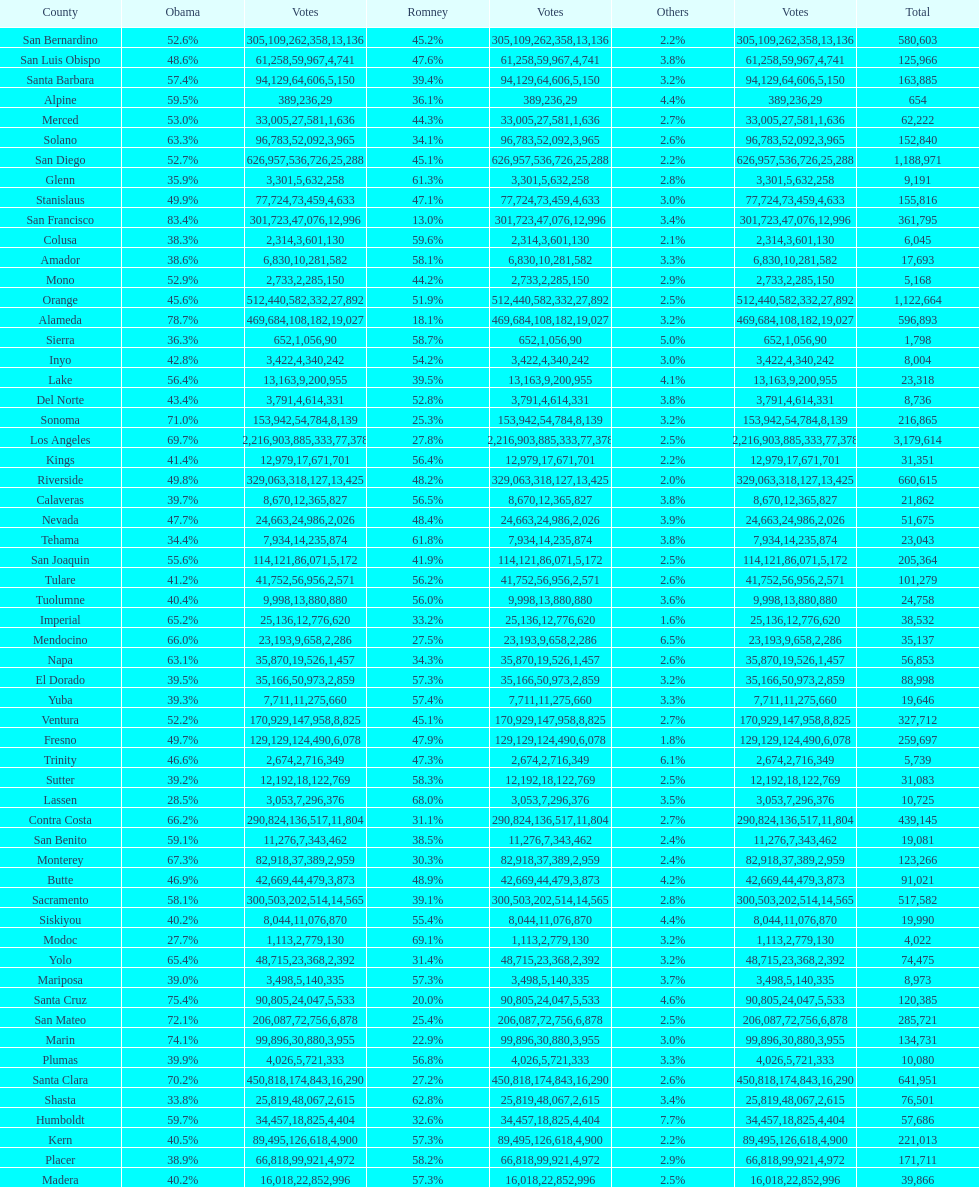How many counties had at least 75% of the votes for obama? 3. 